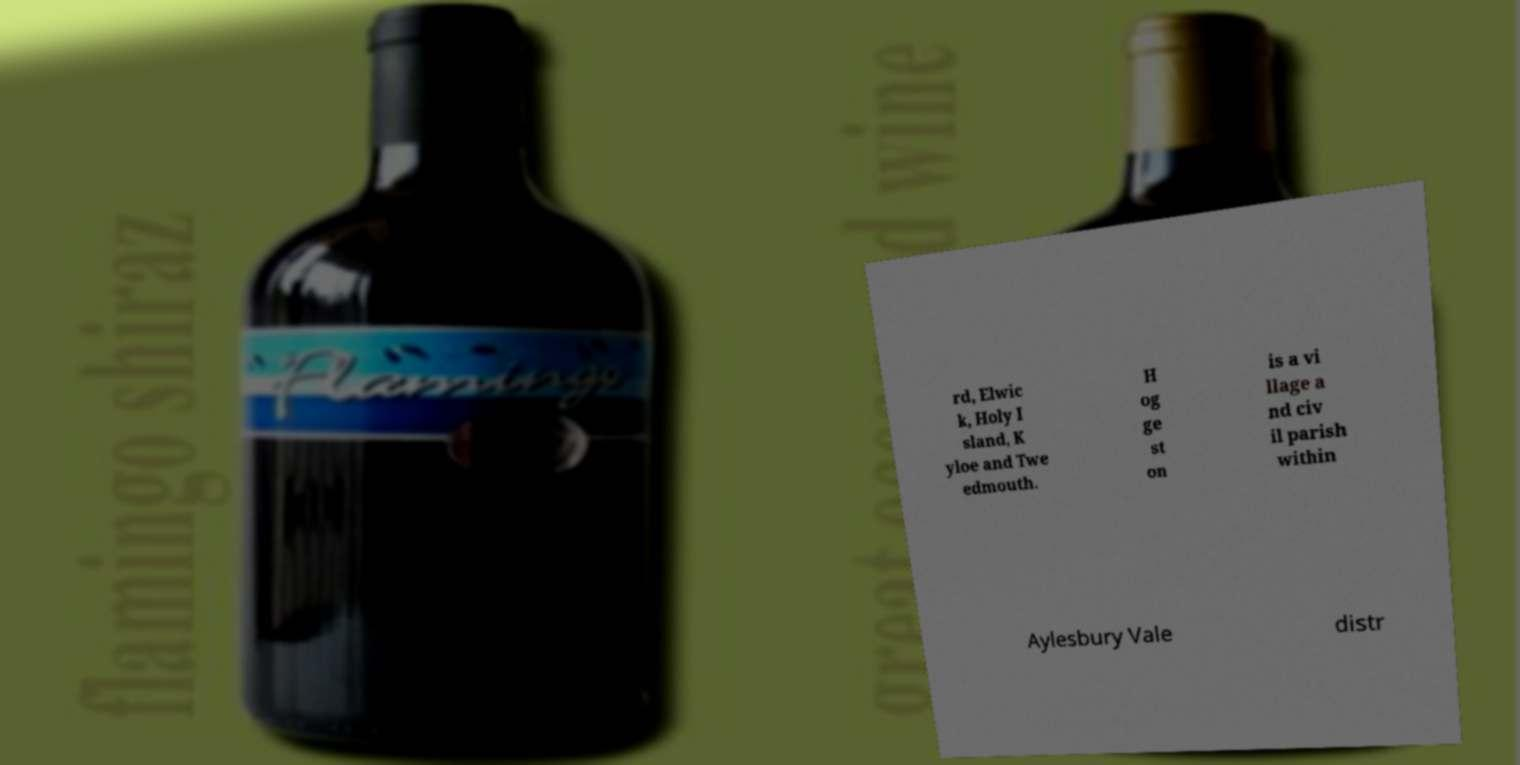Can you accurately transcribe the text from the provided image for me? rd, Elwic k, Holy I sland, K yloe and Twe edmouth. H og ge st on is a vi llage a nd civ il parish within Aylesbury Vale distr 